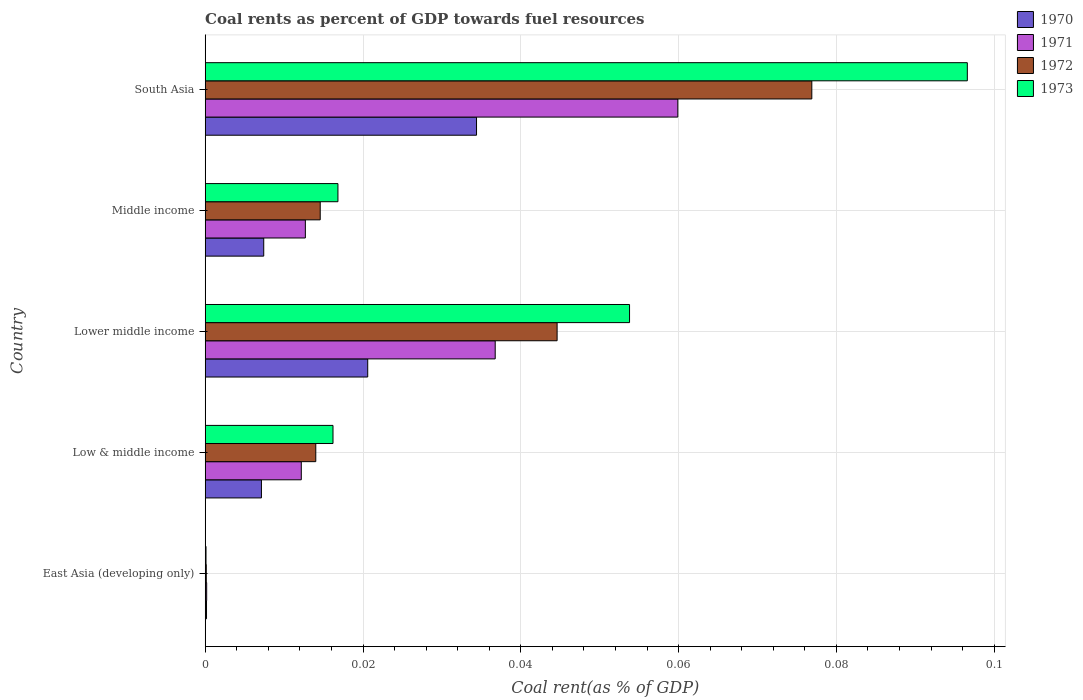How many different coloured bars are there?
Ensure brevity in your answer.  4. How many groups of bars are there?
Give a very brief answer. 5. Are the number of bars per tick equal to the number of legend labels?
Provide a short and direct response. Yes. Are the number of bars on each tick of the Y-axis equal?
Your response must be concise. Yes. How many bars are there on the 1st tick from the top?
Your answer should be compact. 4. How many bars are there on the 1st tick from the bottom?
Give a very brief answer. 4. What is the label of the 2nd group of bars from the top?
Your answer should be compact. Middle income. In how many cases, is the number of bars for a given country not equal to the number of legend labels?
Ensure brevity in your answer.  0. What is the coal rent in 1972 in East Asia (developing only)?
Provide a succinct answer. 0. Across all countries, what is the maximum coal rent in 1973?
Provide a short and direct response. 0.1. Across all countries, what is the minimum coal rent in 1970?
Your answer should be very brief. 0. In which country was the coal rent in 1973 minimum?
Provide a succinct answer. East Asia (developing only). What is the total coal rent in 1970 in the graph?
Make the answer very short. 0.07. What is the difference between the coal rent in 1972 in Low & middle income and that in Middle income?
Your response must be concise. -0. What is the difference between the coal rent in 1970 in Lower middle income and the coal rent in 1973 in East Asia (developing only)?
Keep it short and to the point. 0.02. What is the average coal rent in 1970 per country?
Your response must be concise. 0.01. What is the difference between the coal rent in 1970 and coal rent in 1973 in Middle income?
Your answer should be compact. -0.01. In how many countries, is the coal rent in 1972 greater than 0.028 %?
Your answer should be very brief. 2. What is the ratio of the coal rent in 1972 in Low & middle income to that in Lower middle income?
Offer a terse response. 0.31. Is the coal rent in 1973 in East Asia (developing only) less than that in Middle income?
Your answer should be very brief. Yes. Is the difference between the coal rent in 1970 in Low & middle income and South Asia greater than the difference between the coal rent in 1973 in Low & middle income and South Asia?
Offer a terse response. Yes. What is the difference between the highest and the second highest coal rent in 1971?
Keep it short and to the point. 0.02. What is the difference between the highest and the lowest coal rent in 1970?
Your answer should be very brief. 0.03. Is the sum of the coal rent in 1971 in East Asia (developing only) and South Asia greater than the maximum coal rent in 1970 across all countries?
Give a very brief answer. Yes. What does the 2nd bar from the bottom in Lower middle income represents?
Offer a very short reply. 1971. How many bars are there?
Ensure brevity in your answer.  20. Are the values on the major ticks of X-axis written in scientific E-notation?
Your answer should be very brief. No. Does the graph contain any zero values?
Provide a short and direct response. No. What is the title of the graph?
Offer a very short reply. Coal rents as percent of GDP towards fuel resources. What is the label or title of the X-axis?
Offer a terse response. Coal rent(as % of GDP). What is the Coal rent(as % of GDP) of 1970 in East Asia (developing only)?
Your answer should be compact. 0. What is the Coal rent(as % of GDP) of 1971 in East Asia (developing only)?
Offer a very short reply. 0. What is the Coal rent(as % of GDP) of 1972 in East Asia (developing only)?
Your response must be concise. 0. What is the Coal rent(as % of GDP) in 1973 in East Asia (developing only)?
Your response must be concise. 0. What is the Coal rent(as % of GDP) of 1970 in Low & middle income?
Your answer should be compact. 0.01. What is the Coal rent(as % of GDP) in 1971 in Low & middle income?
Give a very brief answer. 0.01. What is the Coal rent(as % of GDP) in 1972 in Low & middle income?
Your answer should be very brief. 0.01. What is the Coal rent(as % of GDP) in 1973 in Low & middle income?
Your answer should be very brief. 0.02. What is the Coal rent(as % of GDP) of 1970 in Lower middle income?
Your response must be concise. 0.02. What is the Coal rent(as % of GDP) of 1971 in Lower middle income?
Your answer should be very brief. 0.04. What is the Coal rent(as % of GDP) in 1972 in Lower middle income?
Ensure brevity in your answer.  0.04. What is the Coal rent(as % of GDP) in 1973 in Lower middle income?
Provide a short and direct response. 0.05. What is the Coal rent(as % of GDP) in 1970 in Middle income?
Your answer should be very brief. 0.01. What is the Coal rent(as % of GDP) in 1971 in Middle income?
Give a very brief answer. 0.01. What is the Coal rent(as % of GDP) in 1972 in Middle income?
Offer a terse response. 0.01. What is the Coal rent(as % of GDP) of 1973 in Middle income?
Your answer should be very brief. 0.02. What is the Coal rent(as % of GDP) of 1970 in South Asia?
Provide a short and direct response. 0.03. What is the Coal rent(as % of GDP) of 1971 in South Asia?
Offer a terse response. 0.06. What is the Coal rent(as % of GDP) of 1972 in South Asia?
Your answer should be compact. 0.08. What is the Coal rent(as % of GDP) in 1973 in South Asia?
Ensure brevity in your answer.  0.1. Across all countries, what is the maximum Coal rent(as % of GDP) of 1970?
Make the answer very short. 0.03. Across all countries, what is the maximum Coal rent(as % of GDP) of 1971?
Your answer should be very brief. 0.06. Across all countries, what is the maximum Coal rent(as % of GDP) of 1972?
Offer a terse response. 0.08. Across all countries, what is the maximum Coal rent(as % of GDP) in 1973?
Offer a very short reply. 0.1. Across all countries, what is the minimum Coal rent(as % of GDP) of 1970?
Keep it short and to the point. 0. Across all countries, what is the minimum Coal rent(as % of GDP) in 1971?
Your response must be concise. 0. Across all countries, what is the minimum Coal rent(as % of GDP) of 1972?
Provide a succinct answer. 0. Across all countries, what is the minimum Coal rent(as % of GDP) of 1973?
Provide a short and direct response. 0. What is the total Coal rent(as % of GDP) in 1970 in the graph?
Provide a succinct answer. 0.07. What is the total Coal rent(as % of GDP) of 1971 in the graph?
Offer a terse response. 0.12. What is the total Coal rent(as % of GDP) of 1972 in the graph?
Provide a short and direct response. 0.15. What is the total Coal rent(as % of GDP) of 1973 in the graph?
Offer a very short reply. 0.18. What is the difference between the Coal rent(as % of GDP) in 1970 in East Asia (developing only) and that in Low & middle income?
Provide a succinct answer. -0.01. What is the difference between the Coal rent(as % of GDP) in 1971 in East Asia (developing only) and that in Low & middle income?
Offer a terse response. -0.01. What is the difference between the Coal rent(as % of GDP) of 1972 in East Asia (developing only) and that in Low & middle income?
Provide a succinct answer. -0.01. What is the difference between the Coal rent(as % of GDP) of 1973 in East Asia (developing only) and that in Low & middle income?
Make the answer very short. -0.02. What is the difference between the Coal rent(as % of GDP) of 1970 in East Asia (developing only) and that in Lower middle income?
Your answer should be very brief. -0.02. What is the difference between the Coal rent(as % of GDP) of 1971 in East Asia (developing only) and that in Lower middle income?
Your answer should be very brief. -0.04. What is the difference between the Coal rent(as % of GDP) in 1972 in East Asia (developing only) and that in Lower middle income?
Provide a succinct answer. -0.04. What is the difference between the Coal rent(as % of GDP) of 1973 in East Asia (developing only) and that in Lower middle income?
Ensure brevity in your answer.  -0.05. What is the difference between the Coal rent(as % of GDP) of 1970 in East Asia (developing only) and that in Middle income?
Offer a terse response. -0.01. What is the difference between the Coal rent(as % of GDP) in 1971 in East Asia (developing only) and that in Middle income?
Your answer should be compact. -0.01. What is the difference between the Coal rent(as % of GDP) in 1972 in East Asia (developing only) and that in Middle income?
Offer a terse response. -0.01. What is the difference between the Coal rent(as % of GDP) of 1973 in East Asia (developing only) and that in Middle income?
Keep it short and to the point. -0.02. What is the difference between the Coal rent(as % of GDP) of 1970 in East Asia (developing only) and that in South Asia?
Keep it short and to the point. -0.03. What is the difference between the Coal rent(as % of GDP) in 1971 in East Asia (developing only) and that in South Asia?
Ensure brevity in your answer.  -0.06. What is the difference between the Coal rent(as % of GDP) of 1972 in East Asia (developing only) and that in South Asia?
Provide a short and direct response. -0.08. What is the difference between the Coal rent(as % of GDP) in 1973 in East Asia (developing only) and that in South Asia?
Your answer should be compact. -0.1. What is the difference between the Coal rent(as % of GDP) in 1970 in Low & middle income and that in Lower middle income?
Ensure brevity in your answer.  -0.01. What is the difference between the Coal rent(as % of GDP) of 1971 in Low & middle income and that in Lower middle income?
Provide a short and direct response. -0.02. What is the difference between the Coal rent(as % of GDP) of 1972 in Low & middle income and that in Lower middle income?
Ensure brevity in your answer.  -0.03. What is the difference between the Coal rent(as % of GDP) in 1973 in Low & middle income and that in Lower middle income?
Offer a terse response. -0.04. What is the difference between the Coal rent(as % of GDP) in 1970 in Low & middle income and that in Middle income?
Your response must be concise. -0. What is the difference between the Coal rent(as % of GDP) of 1971 in Low & middle income and that in Middle income?
Make the answer very short. -0. What is the difference between the Coal rent(as % of GDP) of 1972 in Low & middle income and that in Middle income?
Your answer should be compact. -0. What is the difference between the Coal rent(as % of GDP) in 1973 in Low & middle income and that in Middle income?
Give a very brief answer. -0. What is the difference between the Coal rent(as % of GDP) of 1970 in Low & middle income and that in South Asia?
Offer a terse response. -0.03. What is the difference between the Coal rent(as % of GDP) of 1971 in Low & middle income and that in South Asia?
Keep it short and to the point. -0.05. What is the difference between the Coal rent(as % of GDP) of 1972 in Low & middle income and that in South Asia?
Keep it short and to the point. -0.06. What is the difference between the Coal rent(as % of GDP) in 1973 in Low & middle income and that in South Asia?
Provide a short and direct response. -0.08. What is the difference between the Coal rent(as % of GDP) of 1970 in Lower middle income and that in Middle income?
Your answer should be compact. 0.01. What is the difference between the Coal rent(as % of GDP) of 1971 in Lower middle income and that in Middle income?
Offer a terse response. 0.02. What is the difference between the Coal rent(as % of GDP) of 1973 in Lower middle income and that in Middle income?
Keep it short and to the point. 0.04. What is the difference between the Coal rent(as % of GDP) of 1970 in Lower middle income and that in South Asia?
Provide a succinct answer. -0.01. What is the difference between the Coal rent(as % of GDP) of 1971 in Lower middle income and that in South Asia?
Provide a succinct answer. -0.02. What is the difference between the Coal rent(as % of GDP) of 1972 in Lower middle income and that in South Asia?
Your answer should be compact. -0.03. What is the difference between the Coal rent(as % of GDP) of 1973 in Lower middle income and that in South Asia?
Provide a short and direct response. -0.04. What is the difference between the Coal rent(as % of GDP) of 1970 in Middle income and that in South Asia?
Provide a succinct answer. -0.03. What is the difference between the Coal rent(as % of GDP) in 1971 in Middle income and that in South Asia?
Offer a very short reply. -0.05. What is the difference between the Coal rent(as % of GDP) in 1972 in Middle income and that in South Asia?
Your response must be concise. -0.06. What is the difference between the Coal rent(as % of GDP) of 1973 in Middle income and that in South Asia?
Your response must be concise. -0.08. What is the difference between the Coal rent(as % of GDP) of 1970 in East Asia (developing only) and the Coal rent(as % of GDP) of 1971 in Low & middle income?
Provide a short and direct response. -0.01. What is the difference between the Coal rent(as % of GDP) in 1970 in East Asia (developing only) and the Coal rent(as % of GDP) in 1972 in Low & middle income?
Your answer should be compact. -0.01. What is the difference between the Coal rent(as % of GDP) of 1970 in East Asia (developing only) and the Coal rent(as % of GDP) of 1973 in Low & middle income?
Keep it short and to the point. -0.02. What is the difference between the Coal rent(as % of GDP) in 1971 in East Asia (developing only) and the Coal rent(as % of GDP) in 1972 in Low & middle income?
Give a very brief answer. -0.01. What is the difference between the Coal rent(as % of GDP) in 1971 in East Asia (developing only) and the Coal rent(as % of GDP) in 1973 in Low & middle income?
Keep it short and to the point. -0.02. What is the difference between the Coal rent(as % of GDP) in 1972 in East Asia (developing only) and the Coal rent(as % of GDP) in 1973 in Low & middle income?
Keep it short and to the point. -0.02. What is the difference between the Coal rent(as % of GDP) in 1970 in East Asia (developing only) and the Coal rent(as % of GDP) in 1971 in Lower middle income?
Provide a succinct answer. -0.04. What is the difference between the Coal rent(as % of GDP) in 1970 in East Asia (developing only) and the Coal rent(as % of GDP) in 1972 in Lower middle income?
Your response must be concise. -0.04. What is the difference between the Coal rent(as % of GDP) of 1970 in East Asia (developing only) and the Coal rent(as % of GDP) of 1973 in Lower middle income?
Give a very brief answer. -0.05. What is the difference between the Coal rent(as % of GDP) in 1971 in East Asia (developing only) and the Coal rent(as % of GDP) in 1972 in Lower middle income?
Provide a succinct answer. -0.04. What is the difference between the Coal rent(as % of GDP) in 1971 in East Asia (developing only) and the Coal rent(as % of GDP) in 1973 in Lower middle income?
Your answer should be very brief. -0.05. What is the difference between the Coal rent(as % of GDP) of 1972 in East Asia (developing only) and the Coal rent(as % of GDP) of 1973 in Lower middle income?
Offer a very short reply. -0.05. What is the difference between the Coal rent(as % of GDP) of 1970 in East Asia (developing only) and the Coal rent(as % of GDP) of 1971 in Middle income?
Keep it short and to the point. -0.01. What is the difference between the Coal rent(as % of GDP) in 1970 in East Asia (developing only) and the Coal rent(as % of GDP) in 1972 in Middle income?
Offer a terse response. -0.01. What is the difference between the Coal rent(as % of GDP) in 1970 in East Asia (developing only) and the Coal rent(as % of GDP) in 1973 in Middle income?
Make the answer very short. -0.02. What is the difference between the Coal rent(as % of GDP) of 1971 in East Asia (developing only) and the Coal rent(as % of GDP) of 1972 in Middle income?
Make the answer very short. -0.01. What is the difference between the Coal rent(as % of GDP) of 1971 in East Asia (developing only) and the Coal rent(as % of GDP) of 1973 in Middle income?
Give a very brief answer. -0.02. What is the difference between the Coal rent(as % of GDP) of 1972 in East Asia (developing only) and the Coal rent(as % of GDP) of 1973 in Middle income?
Your answer should be compact. -0.02. What is the difference between the Coal rent(as % of GDP) in 1970 in East Asia (developing only) and the Coal rent(as % of GDP) in 1971 in South Asia?
Make the answer very short. -0.06. What is the difference between the Coal rent(as % of GDP) in 1970 in East Asia (developing only) and the Coal rent(as % of GDP) in 1972 in South Asia?
Offer a very short reply. -0.08. What is the difference between the Coal rent(as % of GDP) in 1970 in East Asia (developing only) and the Coal rent(as % of GDP) in 1973 in South Asia?
Your response must be concise. -0.1. What is the difference between the Coal rent(as % of GDP) of 1971 in East Asia (developing only) and the Coal rent(as % of GDP) of 1972 in South Asia?
Your answer should be very brief. -0.08. What is the difference between the Coal rent(as % of GDP) in 1971 in East Asia (developing only) and the Coal rent(as % of GDP) in 1973 in South Asia?
Give a very brief answer. -0.1. What is the difference between the Coal rent(as % of GDP) of 1972 in East Asia (developing only) and the Coal rent(as % of GDP) of 1973 in South Asia?
Provide a succinct answer. -0.1. What is the difference between the Coal rent(as % of GDP) of 1970 in Low & middle income and the Coal rent(as % of GDP) of 1971 in Lower middle income?
Offer a terse response. -0.03. What is the difference between the Coal rent(as % of GDP) in 1970 in Low & middle income and the Coal rent(as % of GDP) in 1972 in Lower middle income?
Give a very brief answer. -0.04. What is the difference between the Coal rent(as % of GDP) of 1970 in Low & middle income and the Coal rent(as % of GDP) of 1973 in Lower middle income?
Your answer should be very brief. -0.05. What is the difference between the Coal rent(as % of GDP) of 1971 in Low & middle income and the Coal rent(as % of GDP) of 1972 in Lower middle income?
Your answer should be very brief. -0.03. What is the difference between the Coal rent(as % of GDP) in 1971 in Low & middle income and the Coal rent(as % of GDP) in 1973 in Lower middle income?
Your answer should be compact. -0.04. What is the difference between the Coal rent(as % of GDP) of 1972 in Low & middle income and the Coal rent(as % of GDP) of 1973 in Lower middle income?
Ensure brevity in your answer.  -0.04. What is the difference between the Coal rent(as % of GDP) in 1970 in Low & middle income and the Coal rent(as % of GDP) in 1971 in Middle income?
Give a very brief answer. -0.01. What is the difference between the Coal rent(as % of GDP) in 1970 in Low & middle income and the Coal rent(as % of GDP) in 1972 in Middle income?
Give a very brief answer. -0.01. What is the difference between the Coal rent(as % of GDP) of 1970 in Low & middle income and the Coal rent(as % of GDP) of 1973 in Middle income?
Make the answer very short. -0.01. What is the difference between the Coal rent(as % of GDP) in 1971 in Low & middle income and the Coal rent(as % of GDP) in 1972 in Middle income?
Provide a short and direct response. -0. What is the difference between the Coal rent(as % of GDP) in 1971 in Low & middle income and the Coal rent(as % of GDP) in 1973 in Middle income?
Make the answer very short. -0. What is the difference between the Coal rent(as % of GDP) of 1972 in Low & middle income and the Coal rent(as % of GDP) of 1973 in Middle income?
Ensure brevity in your answer.  -0. What is the difference between the Coal rent(as % of GDP) of 1970 in Low & middle income and the Coal rent(as % of GDP) of 1971 in South Asia?
Provide a short and direct response. -0.05. What is the difference between the Coal rent(as % of GDP) in 1970 in Low & middle income and the Coal rent(as % of GDP) in 1972 in South Asia?
Make the answer very short. -0.07. What is the difference between the Coal rent(as % of GDP) in 1970 in Low & middle income and the Coal rent(as % of GDP) in 1973 in South Asia?
Offer a terse response. -0.09. What is the difference between the Coal rent(as % of GDP) in 1971 in Low & middle income and the Coal rent(as % of GDP) in 1972 in South Asia?
Offer a terse response. -0.06. What is the difference between the Coal rent(as % of GDP) of 1971 in Low & middle income and the Coal rent(as % of GDP) of 1973 in South Asia?
Give a very brief answer. -0.08. What is the difference between the Coal rent(as % of GDP) in 1972 in Low & middle income and the Coal rent(as % of GDP) in 1973 in South Asia?
Your response must be concise. -0.08. What is the difference between the Coal rent(as % of GDP) in 1970 in Lower middle income and the Coal rent(as % of GDP) in 1971 in Middle income?
Offer a very short reply. 0.01. What is the difference between the Coal rent(as % of GDP) of 1970 in Lower middle income and the Coal rent(as % of GDP) of 1972 in Middle income?
Your answer should be compact. 0.01. What is the difference between the Coal rent(as % of GDP) in 1970 in Lower middle income and the Coal rent(as % of GDP) in 1973 in Middle income?
Your answer should be very brief. 0. What is the difference between the Coal rent(as % of GDP) of 1971 in Lower middle income and the Coal rent(as % of GDP) of 1972 in Middle income?
Give a very brief answer. 0.02. What is the difference between the Coal rent(as % of GDP) in 1971 in Lower middle income and the Coal rent(as % of GDP) in 1973 in Middle income?
Provide a succinct answer. 0.02. What is the difference between the Coal rent(as % of GDP) in 1972 in Lower middle income and the Coal rent(as % of GDP) in 1973 in Middle income?
Offer a very short reply. 0.03. What is the difference between the Coal rent(as % of GDP) of 1970 in Lower middle income and the Coal rent(as % of GDP) of 1971 in South Asia?
Your answer should be compact. -0.04. What is the difference between the Coal rent(as % of GDP) in 1970 in Lower middle income and the Coal rent(as % of GDP) in 1972 in South Asia?
Offer a terse response. -0.06. What is the difference between the Coal rent(as % of GDP) in 1970 in Lower middle income and the Coal rent(as % of GDP) in 1973 in South Asia?
Your response must be concise. -0.08. What is the difference between the Coal rent(as % of GDP) of 1971 in Lower middle income and the Coal rent(as % of GDP) of 1972 in South Asia?
Keep it short and to the point. -0.04. What is the difference between the Coal rent(as % of GDP) of 1971 in Lower middle income and the Coal rent(as % of GDP) of 1973 in South Asia?
Your answer should be compact. -0.06. What is the difference between the Coal rent(as % of GDP) of 1972 in Lower middle income and the Coal rent(as % of GDP) of 1973 in South Asia?
Your response must be concise. -0.05. What is the difference between the Coal rent(as % of GDP) in 1970 in Middle income and the Coal rent(as % of GDP) in 1971 in South Asia?
Offer a very short reply. -0.05. What is the difference between the Coal rent(as % of GDP) in 1970 in Middle income and the Coal rent(as % of GDP) in 1972 in South Asia?
Your answer should be very brief. -0.07. What is the difference between the Coal rent(as % of GDP) in 1970 in Middle income and the Coal rent(as % of GDP) in 1973 in South Asia?
Your response must be concise. -0.09. What is the difference between the Coal rent(as % of GDP) of 1971 in Middle income and the Coal rent(as % of GDP) of 1972 in South Asia?
Provide a succinct answer. -0.06. What is the difference between the Coal rent(as % of GDP) of 1971 in Middle income and the Coal rent(as % of GDP) of 1973 in South Asia?
Keep it short and to the point. -0.08. What is the difference between the Coal rent(as % of GDP) in 1972 in Middle income and the Coal rent(as % of GDP) in 1973 in South Asia?
Offer a very short reply. -0.08. What is the average Coal rent(as % of GDP) in 1970 per country?
Keep it short and to the point. 0.01. What is the average Coal rent(as % of GDP) of 1971 per country?
Provide a short and direct response. 0.02. What is the average Coal rent(as % of GDP) in 1972 per country?
Your answer should be compact. 0.03. What is the average Coal rent(as % of GDP) in 1973 per country?
Make the answer very short. 0.04. What is the difference between the Coal rent(as % of GDP) in 1970 and Coal rent(as % of GDP) in 1971 in East Asia (developing only)?
Offer a very short reply. -0. What is the difference between the Coal rent(as % of GDP) in 1971 and Coal rent(as % of GDP) in 1973 in East Asia (developing only)?
Ensure brevity in your answer.  0. What is the difference between the Coal rent(as % of GDP) of 1970 and Coal rent(as % of GDP) of 1971 in Low & middle income?
Make the answer very short. -0.01. What is the difference between the Coal rent(as % of GDP) of 1970 and Coal rent(as % of GDP) of 1972 in Low & middle income?
Offer a terse response. -0.01. What is the difference between the Coal rent(as % of GDP) in 1970 and Coal rent(as % of GDP) in 1973 in Low & middle income?
Make the answer very short. -0.01. What is the difference between the Coal rent(as % of GDP) of 1971 and Coal rent(as % of GDP) of 1972 in Low & middle income?
Give a very brief answer. -0. What is the difference between the Coal rent(as % of GDP) of 1971 and Coal rent(as % of GDP) of 1973 in Low & middle income?
Offer a very short reply. -0. What is the difference between the Coal rent(as % of GDP) in 1972 and Coal rent(as % of GDP) in 1973 in Low & middle income?
Offer a very short reply. -0. What is the difference between the Coal rent(as % of GDP) of 1970 and Coal rent(as % of GDP) of 1971 in Lower middle income?
Provide a short and direct response. -0.02. What is the difference between the Coal rent(as % of GDP) of 1970 and Coal rent(as % of GDP) of 1972 in Lower middle income?
Offer a terse response. -0.02. What is the difference between the Coal rent(as % of GDP) in 1970 and Coal rent(as % of GDP) in 1973 in Lower middle income?
Your answer should be very brief. -0.03. What is the difference between the Coal rent(as % of GDP) in 1971 and Coal rent(as % of GDP) in 1972 in Lower middle income?
Offer a very short reply. -0.01. What is the difference between the Coal rent(as % of GDP) in 1971 and Coal rent(as % of GDP) in 1973 in Lower middle income?
Provide a succinct answer. -0.02. What is the difference between the Coal rent(as % of GDP) of 1972 and Coal rent(as % of GDP) of 1973 in Lower middle income?
Your answer should be very brief. -0.01. What is the difference between the Coal rent(as % of GDP) of 1970 and Coal rent(as % of GDP) of 1971 in Middle income?
Your response must be concise. -0.01. What is the difference between the Coal rent(as % of GDP) in 1970 and Coal rent(as % of GDP) in 1972 in Middle income?
Give a very brief answer. -0.01. What is the difference between the Coal rent(as % of GDP) of 1970 and Coal rent(as % of GDP) of 1973 in Middle income?
Ensure brevity in your answer.  -0.01. What is the difference between the Coal rent(as % of GDP) of 1971 and Coal rent(as % of GDP) of 1972 in Middle income?
Provide a short and direct response. -0. What is the difference between the Coal rent(as % of GDP) in 1971 and Coal rent(as % of GDP) in 1973 in Middle income?
Offer a terse response. -0. What is the difference between the Coal rent(as % of GDP) in 1972 and Coal rent(as % of GDP) in 1973 in Middle income?
Provide a short and direct response. -0. What is the difference between the Coal rent(as % of GDP) in 1970 and Coal rent(as % of GDP) in 1971 in South Asia?
Provide a short and direct response. -0.03. What is the difference between the Coal rent(as % of GDP) of 1970 and Coal rent(as % of GDP) of 1972 in South Asia?
Give a very brief answer. -0.04. What is the difference between the Coal rent(as % of GDP) in 1970 and Coal rent(as % of GDP) in 1973 in South Asia?
Provide a short and direct response. -0.06. What is the difference between the Coal rent(as % of GDP) of 1971 and Coal rent(as % of GDP) of 1972 in South Asia?
Give a very brief answer. -0.02. What is the difference between the Coal rent(as % of GDP) in 1971 and Coal rent(as % of GDP) in 1973 in South Asia?
Ensure brevity in your answer.  -0.04. What is the difference between the Coal rent(as % of GDP) in 1972 and Coal rent(as % of GDP) in 1973 in South Asia?
Make the answer very short. -0.02. What is the ratio of the Coal rent(as % of GDP) of 1970 in East Asia (developing only) to that in Low & middle income?
Your answer should be very brief. 0.02. What is the ratio of the Coal rent(as % of GDP) of 1971 in East Asia (developing only) to that in Low & middle income?
Your answer should be very brief. 0.02. What is the ratio of the Coal rent(as % of GDP) in 1972 in East Asia (developing only) to that in Low & middle income?
Your response must be concise. 0.01. What is the ratio of the Coal rent(as % of GDP) in 1973 in East Asia (developing only) to that in Low & middle income?
Make the answer very short. 0.01. What is the ratio of the Coal rent(as % of GDP) of 1970 in East Asia (developing only) to that in Lower middle income?
Provide a succinct answer. 0.01. What is the ratio of the Coal rent(as % of GDP) of 1971 in East Asia (developing only) to that in Lower middle income?
Keep it short and to the point. 0.01. What is the ratio of the Coal rent(as % of GDP) of 1972 in East Asia (developing only) to that in Lower middle income?
Keep it short and to the point. 0. What is the ratio of the Coal rent(as % of GDP) in 1973 in East Asia (developing only) to that in Lower middle income?
Keep it short and to the point. 0. What is the ratio of the Coal rent(as % of GDP) in 1970 in East Asia (developing only) to that in Middle income?
Ensure brevity in your answer.  0.02. What is the ratio of the Coal rent(as % of GDP) of 1971 in East Asia (developing only) to that in Middle income?
Your answer should be very brief. 0.01. What is the ratio of the Coal rent(as % of GDP) in 1972 in East Asia (developing only) to that in Middle income?
Offer a very short reply. 0.01. What is the ratio of the Coal rent(as % of GDP) in 1973 in East Asia (developing only) to that in Middle income?
Your answer should be compact. 0.01. What is the ratio of the Coal rent(as % of GDP) in 1970 in East Asia (developing only) to that in South Asia?
Keep it short and to the point. 0. What is the ratio of the Coal rent(as % of GDP) in 1971 in East Asia (developing only) to that in South Asia?
Offer a very short reply. 0. What is the ratio of the Coal rent(as % of GDP) in 1972 in East Asia (developing only) to that in South Asia?
Ensure brevity in your answer.  0. What is the ratio of the Coal rent(as % of GDP) in 1973 in East Asia (developing only) to that in South Asia?
Keep it short and to the point. 0. What is the ratio of the Coal rent(as % of GDP) in 1970 in Low & middle income to that in Lower middle income?
Provide a succinct answer. 0.35. What is the ratio of the Coal rent(as % of GDP) in 1971 in Low & middle income to that in Lower middle income?
Provide a short and direct response. 0.33. What is the ratio of the Coal rent(as % of GDP) in 1972 in Low & middle income to that in Lower middle income?
Give a very brief answer. 0.31. What is the ratio of the Coal rent(as % of GDP) in 1973 in Low & middle income to that in Lower middle income?
Your answer should be compact. 0.3. What is the ratio of the Coal rent(as % of GDP) of 1970 in Low & middle income to that in Middle income?
Your answer should be compact. 0.96. What is the ratio of the Coal rent(as % of GDP) of 1971 in Low & middle income to that in Middle income?
Your answer should be very brief. 0.96. What is the ratio of the Coal rent(as % of GDP) in 1972 in Low & middle income to that in Middle income?
Keep it short and to the point. 0.96. What is the ratio of the Coal rent(as % of GDP) of 1973 in Low & middle income to that in Middle income?
Ensure brevity in your answer.  0.96. What is the ratio of the Coal rent(as % of GDP) of 1970 in Low & middle income to that in South Asia?
Offer a terse response. 0.21. What is the ratio of the Coal rent(as % of GDP) in 1971 in Low & middle income to that in South Asia?
Provide a succinct answer. 0.2. What is the ratio of the Coal rent(as % of GDP) of 1972 in Low & middle income to that in South Asia?
Give a very brief answer. 0.18. What is the ratio of the Coal rent(as % of GDP) in 1973 in Low & middle income to that in South Asia?
Provide a short and direct response. 0.17. What is the ratio of the Coal rent(as % of GDP) in 1970 in Lower middle income to that in Middle income?
Make the answer very short. 2.78. What is the ratio of the Coal rent(as % of GDP) of 1971 in Lower middle income to that in Middle income?
Your answer should be compact. 2.9. What is the ratio of the Coal rent(as % of GDP) in 1972 in Lower middle income to that in Middle income?
Keep it short and to the point. 3.06. What is the ratio of the Coal rent(as % of GDP) in 1973 in Lower middle income to that in Middle income?
Make the answer very short. 3.2. What is the ratio of the Coal rent(as % of GDP) of 1970 in Lower middle income to that in South Asia?
Keep it short and to the point. 0.6. What is the ratio of the Coal rent(as % of GDP) in 1971 in Lower middle income to that in South Asia?
Offer a terse response. 0.61. What is the ratio of the Coal rent(as % of GDP) in 1972 in Lower middle income to that in South Asia?
Make the answer very short. 0.58. What is the ratio of the Coal rent(as % of GDP) in 1973 in Lower middle income to that in South Asia?
Offer a very short reply. 0.56. What is the ratio of the Coal rent(as % of GDP) of 1970 in Middle income to that in South Asia?
Your answer should be very brief. 0.22. What is the ratio of the Coal rent(as % of GDP) in 1971 in Middle income to that in South Asia?
Make the answer very short. 0.21. What is the ratio of the Coal rent(as % of GDP) in 1972 in Middle income to that in South Asia?
Offer a very short reply. 0.19. What is the ratio of the Coal rent(as % of GDP) of 1973 in Middle income to that in South Asia?
Your answer should be very brief. 0.17. What is the difference between the highest and the second highest Coal rent(as % of GDP) of 1970?
Offer a very short reply. 0.01. What is the difference between the highest and the second highest Coal rent(as % of GDP) in 1971?
Give a very brief answer. 0.02. What is the difference between the highest and the second highest Coal rent(as % of GDP) in 1972?
Ensure brevity in your answer.  0.03. What is the difference between the highest and the second highest Coal rent(as % of GDP) in 1973?
Provide a short and direct response. 0.04. What is the difference between the highest and the lowest Coal rent(as % of GDP) of 1970?
Provide a succinct answer. 0.03. What is the difference between the highest and the lowest Coal rent(as % of GDP) in 1971?
Provide a succinct answer. 0.06. What is the difference between the highest and the lowest Coal rent(as % of GDP) of 1972?
Offer a very short reply. 0.08. What is the difference between the highest and the lowest Coal rent(as % of GDP) in 1973?
Make the answer very short. 0.1. 